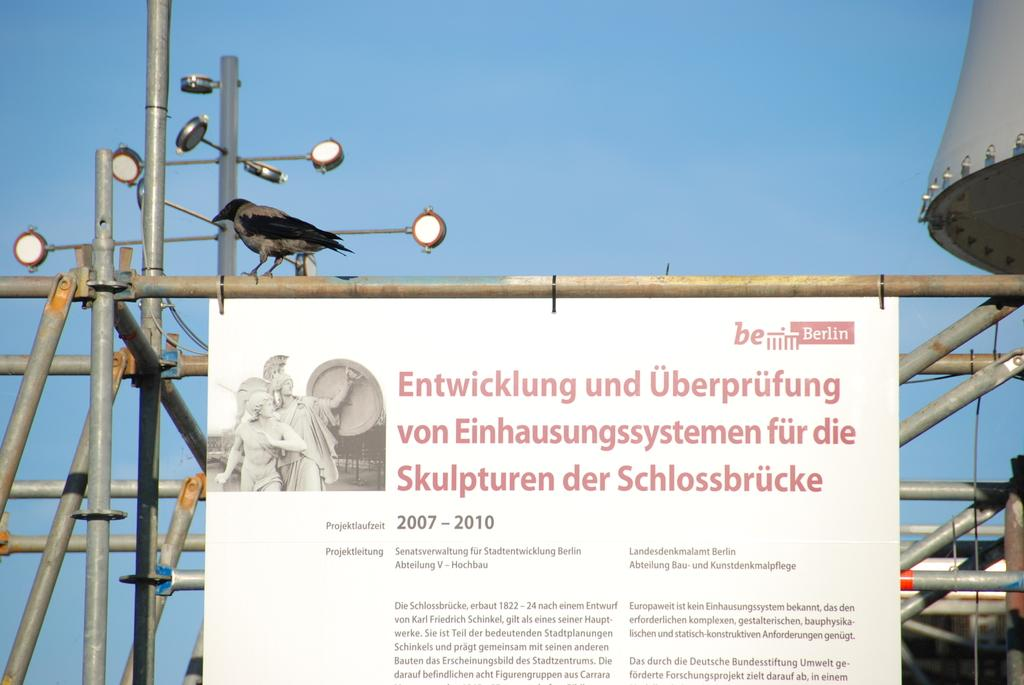<image>
Present a compact description of the photo's key features. a billboard that says 'entwicklung and uberprufung' on it 